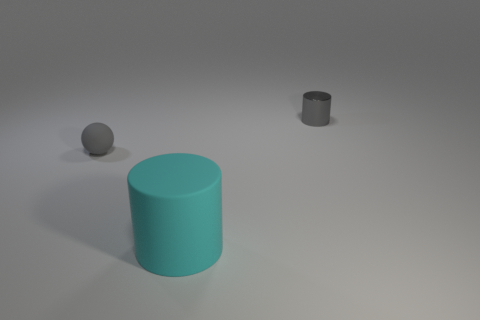How is the lighting affecting the perception of the objects? The lighting in the image is soft and diffused, casting gentle shadows and giving the scene a calm, almost surreal quality. The lack of harsh shadows suggests an even, ambient light source, perhaps simulating an overcast day. This type of lighting minimizes texture details and makes colors appear more uniform. Do the objects seem to have any specific texture? From the image, it's difficult to determine the texture with high accuracy due to the soft lighting. However, the surfaces of the objects appear to be smooth without visible graininess or roughness, which could indicate that they are made from materials like plastic or polished metal. 